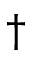<formula> <loc_0><loc_0><loc_500><loc_500>\dagger</formula> 